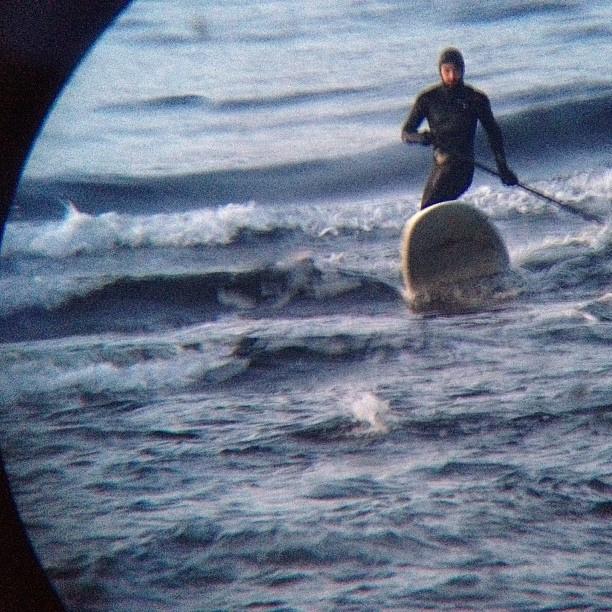Where is the man?
Give a very brief answer. Ocean. What is the man wearing?
Write a very short answer. Wetsuit. What sport is the man participating in?
Keep it brief. Surfing. 